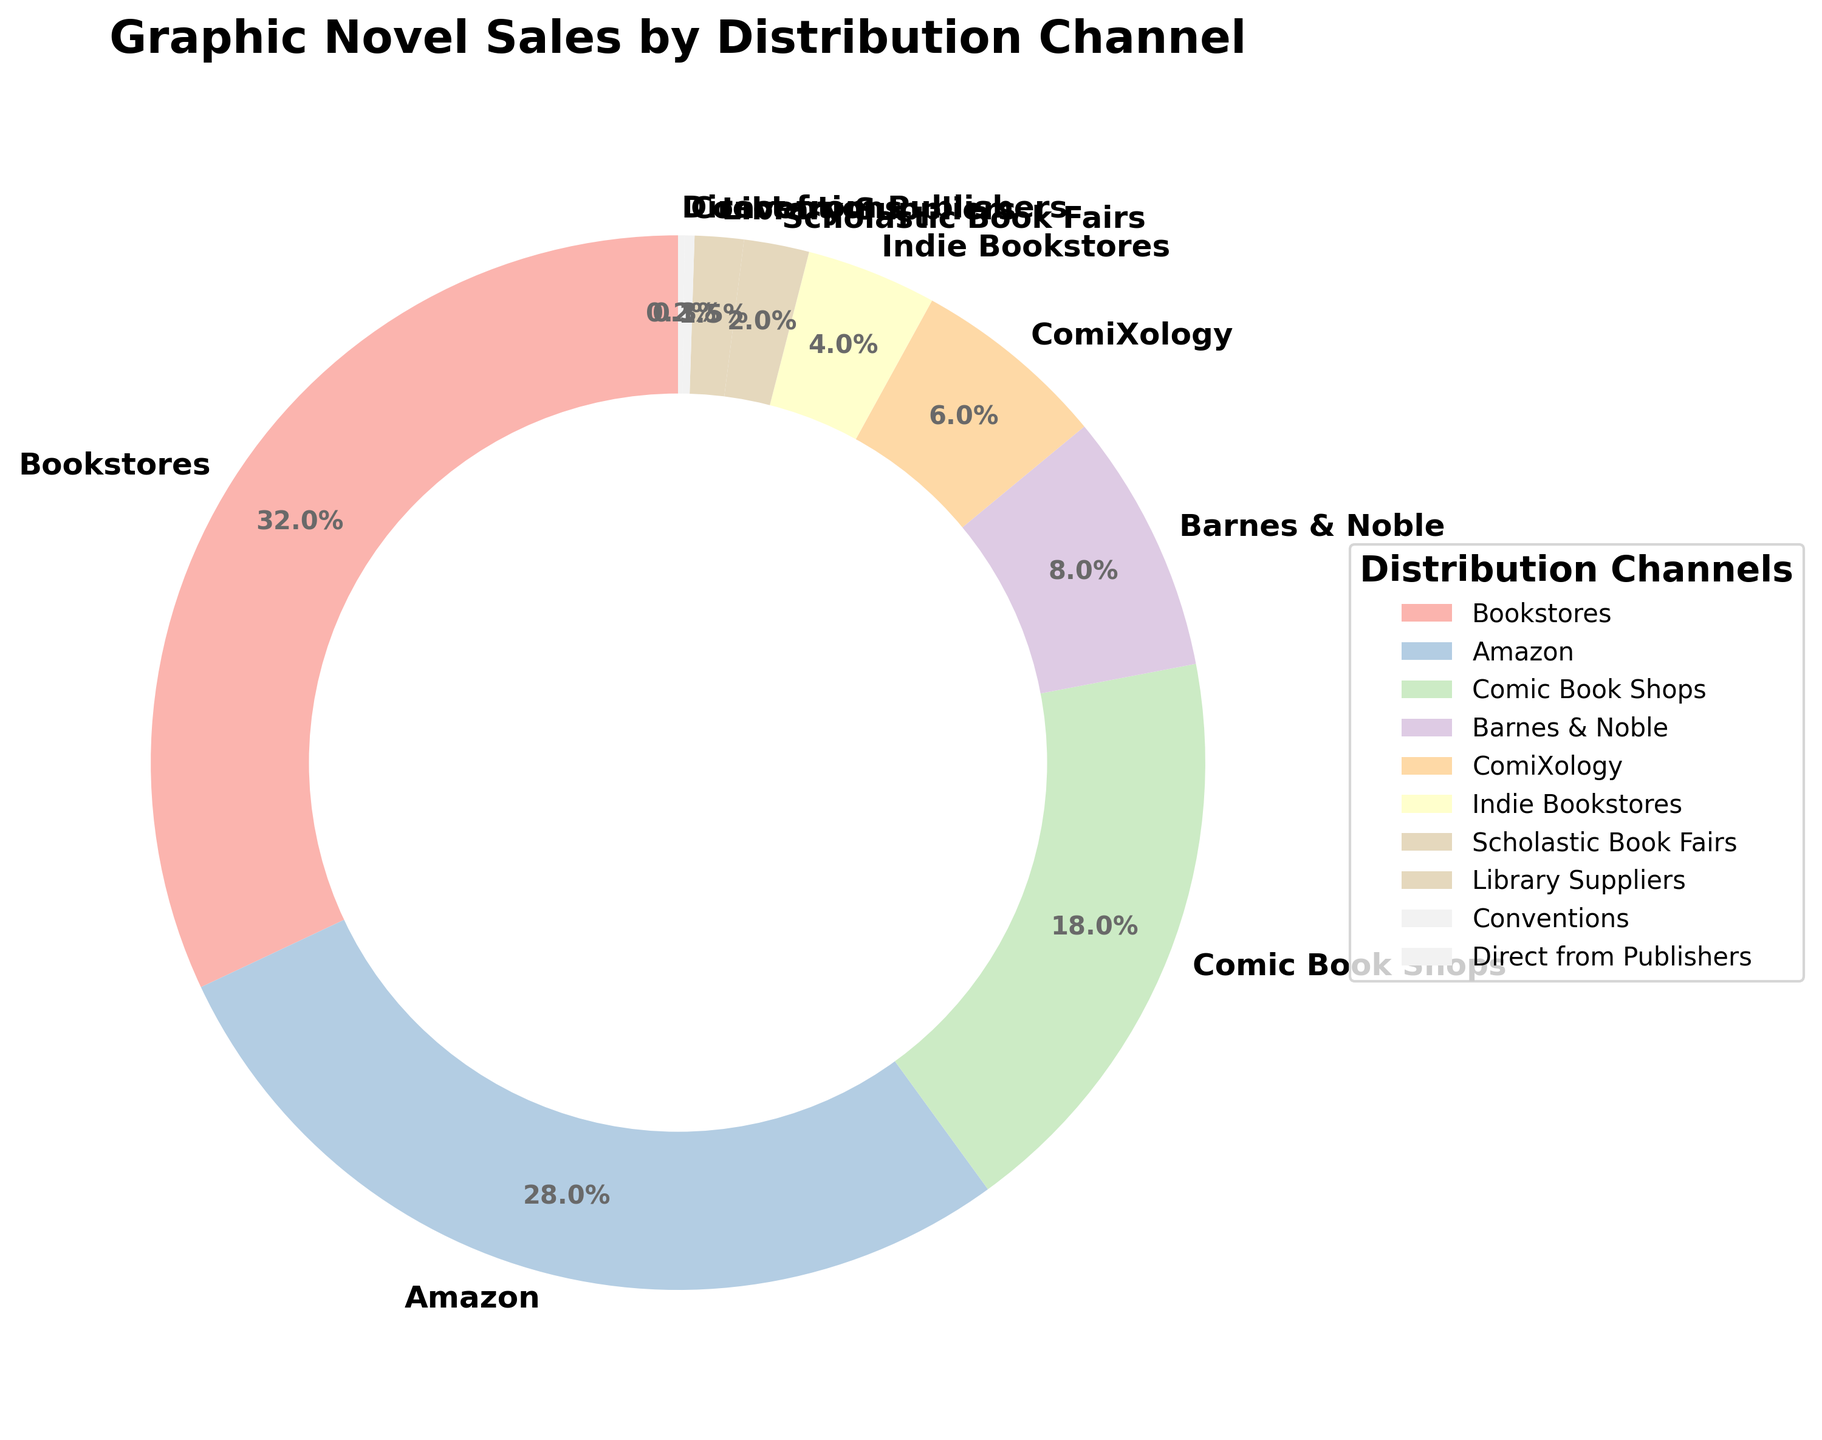Which distribution channel has the highest percentage of graphic novel sales? The figure shows that Bookstores have the largest segment with 32%.
Answer: Bookstores Which distribution channel has the smallest percentage of graphic novel sales? The figure shows that Direct from Publishers has the smallest segment with 0.2%.
Answer: Direct from Publishers What is the combined percentage of the top two distribution channels? The top two channels are Bookstores (32%) and Amazon (28%). Adding them gives 32% + 28% = 60%.
Answer: 60% How does the percentage of sales from Comic Book Shops compare to that from Barnes & Noble? The figure shows Comic Book Shops at 18% and Barnes & Noble at 8%. Since 18% > 8%, Comic Book Shops have a higher percentage.
Answer: Comic Book Shops What's the difference between the sales percentage of ComiXology and Indie Bookstores? ComiXology has 6% and Indie Bookstores have 4%. The difference is 6% - 4% = 2%.
Answer: 2% Which segment color represents Amazon? The colors follow a gradient, and by visual inspection, Amazon is represented by a distinct color in the chart; it's a pastel color near the top of the list.
Answer: Pastel color Are sales from Comic Book Shops and Barnes & Noble together higher or lower than sales from Bookstores? Comic Book Shops are at 18% and Barnes & Noble at 8%. Combined, they account for 18% + 8% = 26%, which is lower than Bookstores' 32%.
Answer: Lower Calculate the total percentage of sales coming from channels that are not bookstores or Amazon. Subtract Bookstores' (32%) and Amazon's (28%) from 100%. Total is 100% - 32% - 28% = 40%.
Answer: 40% What is the sum of the percentages for Scholastic Book Fairs, Library Suppliers, Conventions, and Direct from Publishers? Sum the percentages: 2% + 1.5% + 0.3% + 0.2% = 4%.
Answer: 4% How does the percentage of sales from Indie Bookstores compare to ComiXology and Scholastic Book Fairs combined? ComiXology (6%) + Scholastic Book Fairs (2%) = 8%. Indie Bookstores are 4%, so 8% > 4%.
Answer: Combined is greater 